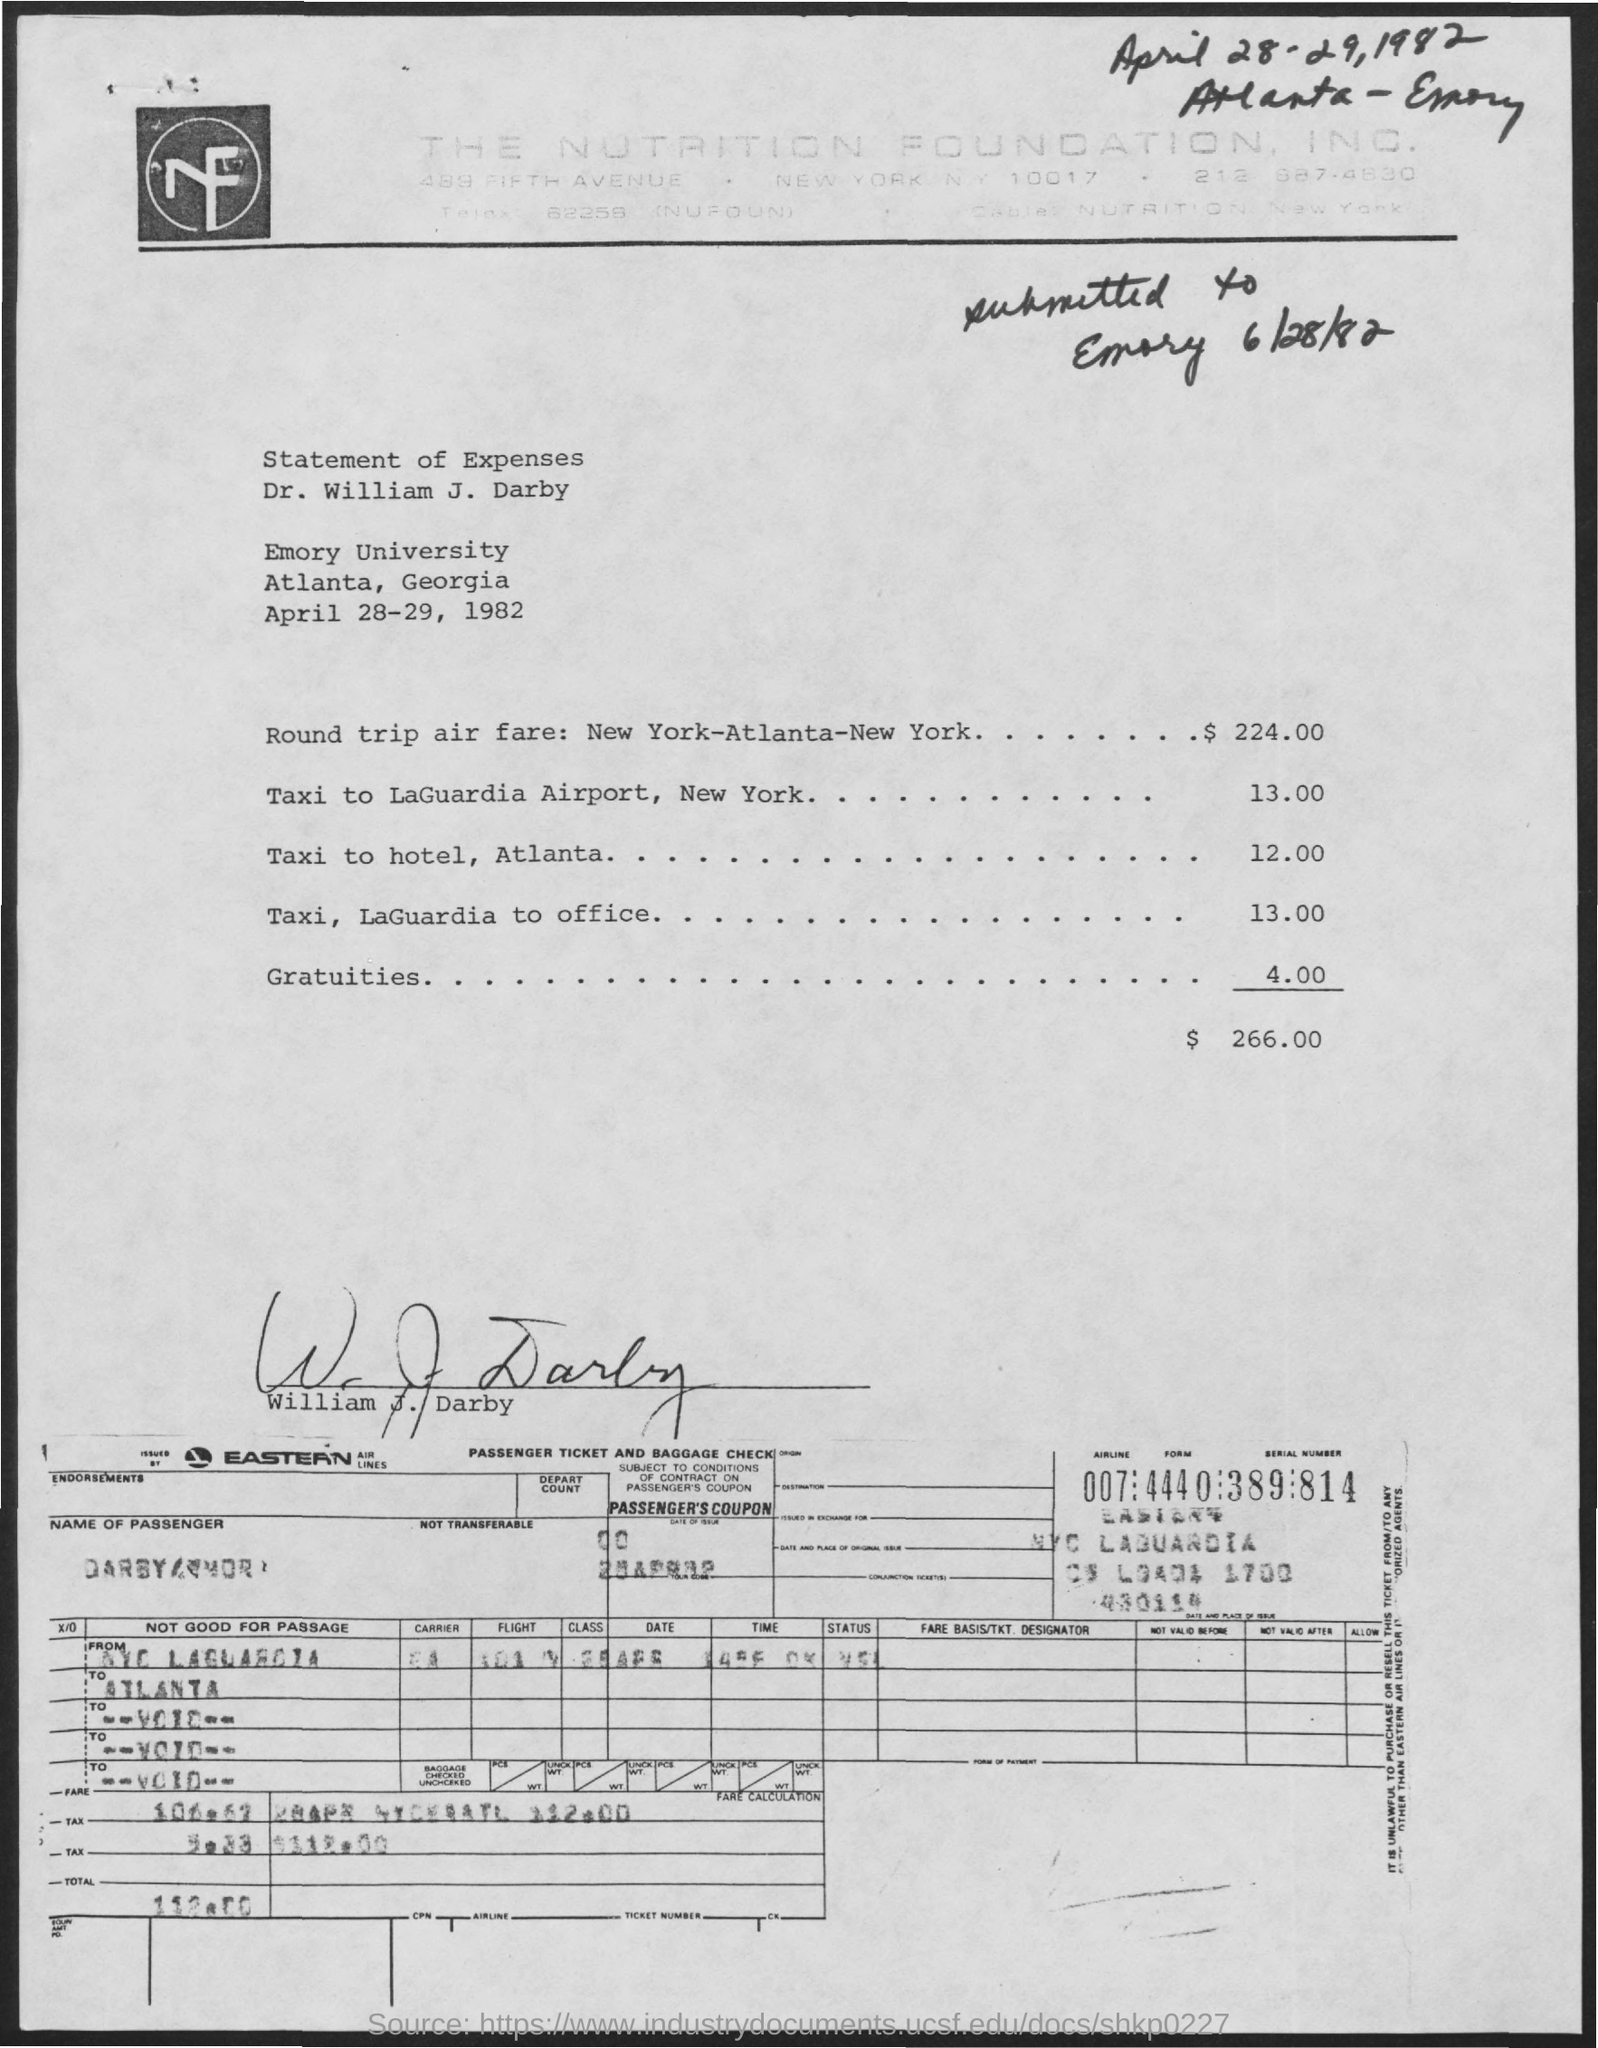Point out several critical features in this image. The Nutrition Foundation, Inc. is the name of the foundation mentioned on the letterhead. The taxi fare to LaGuardia Airport is 13.00. The date mentioned at the top right of the document is April 28-29, 1982. 